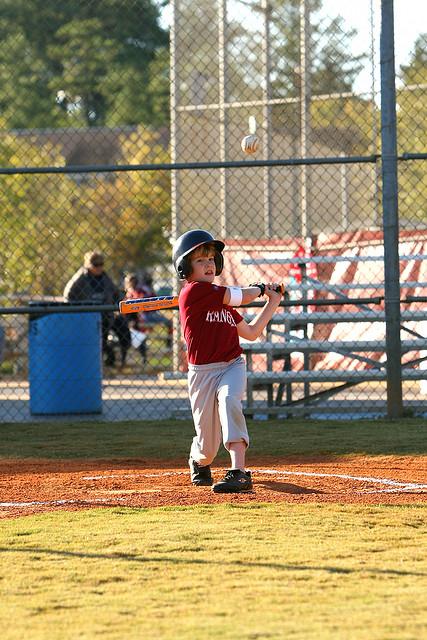What is behind the boy in front?
Be succinct. Fence. What sport is he playing?
Short answer required. Baseball. Has the boy thrown the ball yet?
Keep it brief. Yes. What color is his shirt?
Concise answer only. Red. What is the blue can in the back of the picture used for?
Short answer required. Trash. About how old is the child in the photo?
Answer briefly. 4. Where are the players playing?
Write a very short answer. Baseball. 